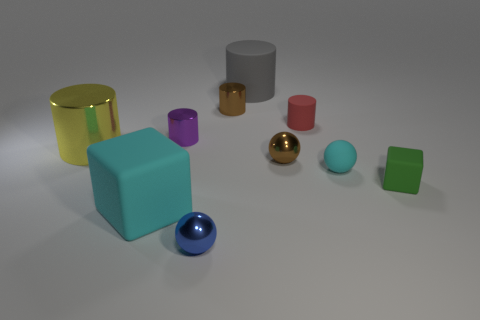What shape is the cyan thing on the left side of the shiny sphere in front of the green rubber object?
Keep it short and to the point. Cube. Is the material of the big gray object the same as the tiny thing to the right of the small cyan sphere?
Provide a short and direct response. Yes. There is a tiny rubber object that is the same color as the big cube; what shape is it?
Your response must be concise. Sphere. What number of brown objects have the same size as the brown metallic cylinder?
Offer a very short reply. 1. Is the number of matte things that are on the left side of the large metal thing less than the number of tiny red cylinders?
Make the answer very short. Yes. What number of tiny blue things are behind the small cyan ball?
Offer a very short reply. 0. What is the size of the brown object that is behind the yellow metallic thing that is behind the cyan rubber thing in front of the tiny cyan object?
Give a very brief answer. Small. There is a green object; does it have the same shape as the red thing in front of the gray cylinder?
Make the answer very short. No. There is a gray cylinder that is made of the same material as the small red cylinder; what is its size?
Ensure brevity in your answer.  Large. Is there anything else that is the same color as the large rubber block?
Offer a terse response. Yes. 